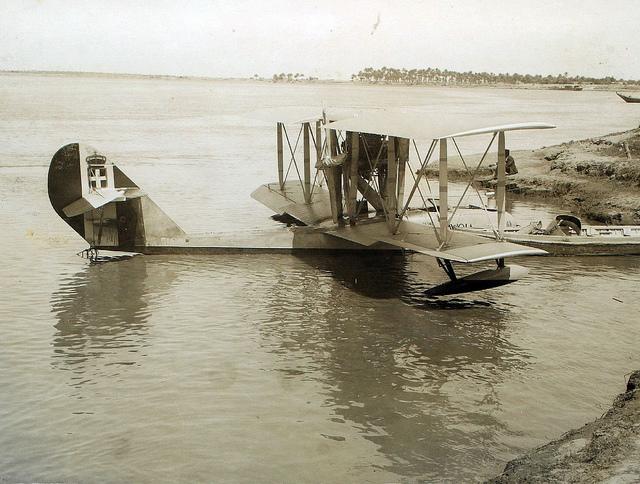Is the plane in the water?
Answer briefly. Yes. Is the plane taking off?
Quick response, please. No. Is the photo in sepia?
Concise answer only. Yes. 